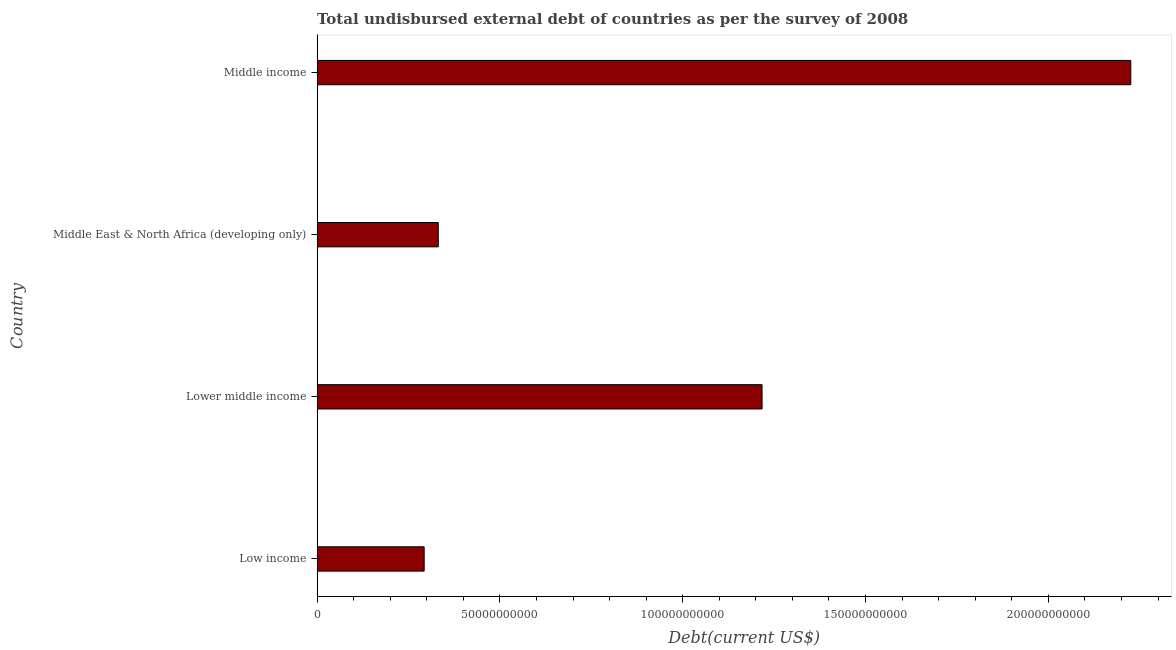Does the graph contain any zero values?
Offer a terse response. No. What is the title of the graph?
Your answer should be compact. Total undisbursed external debt of countries as per the survey of 2008. What is the label or title of the X-axis?
Ensure brevity in your answer.  Debt(current US$). What is the total debt in Lower middle income?
Provide a succinct answer. 1.22e+11. Across all countries, what is the maximum total debt?
Your answer should be compact. 2.23e+11. Across all countries, what is the minimum total debt?
Keep it short and to the point. 2.93e+1. In which country was the total debt minimum?
Your answer should be compact. Low income. What is the sum of the total debt?
Give a very brief answer. 4.07e+11. What is the difference between the total debt in Low income and Lower middle income?
Offer a terse response. -9.24e+1. What is the average total debt per country?
Provide a short and direct response. 1.02e+11. What is the median total debt?
Offer a very short reply. 7.74e+1. What is the ratio of the total debt in Lower middle income to that in Middle income?
Your answer should be very brief. 0.55. Is the difference between the total debt in Lower middle income and Middle East & North Africa (developing only) greater than the difference between any two countries?
Your answer should be very brief. No. What is the difference between the highest and the second highest total debt?
Keep it short and to the point. 1.01e+11. Is the sum of the total debt in Lower middle income and Middle income greater than the maximum total debt across all countries?
Ensure brevity in your answer.  Yes. What is the difference between the highest and the lowest total debt?
Ensure brevity in your answer.  1.93e+11. How many bars are there?
Your response must be concise. 4. How many countries are there in the graph?
Your response must be concise. 4. What is the Debt(current US$) of Low income?
Offer a very short reply. 2.93e+1. What is the Debt(current US$) of Lower middle income?
Keep it short and to the point. 1.22e+11. What is the Debt(current US$) in Middle East & North Africa (developing only)?
Make the answer very short. 3.31e+1. What is the Debt(current US$) in Middle income?
Your answer should be compact. 2.23e+11. What is the difference between the Debt(current US$) in Low income and Lower middle income?
Keep it short and to the point. -9.24e+1. What is the difference between the Debt(current US$) in Low income and Middle East & North Africa (developing only)?
Provide a succinct answer. -3.85e+09. What is the difference between the Debt(current US$) in Low income and Middle income?
Your answer should be very brief. -1.93e+11. What is the difference between the Debt(current US$) in Lower middle income and Middle East & North Africa (developing only)?
Offer a terse response. 8.86e+1. What is the difference between the Debt(current US$) in Lower middle income and Middle income?
Make the answer very short. -1.01e+11. What is the difference between the Debt(current US$) in Middle East & North Africa (developing only) and Middle income?
Give a very brief answer. -1.89e+11. What is the ratio of the Debt(current US$) in Low income to that in Lower middle income?
Provide a short and direct response. 0.24. What is the ratio of the Debt(current US$) in Low income to that in Middle East & North Africa (developing only)?
Your answer should be very brief. 0.88. What is the ratio of the Debt(current US$) in Low income to that in Middle income?
Your response must be concise. 0.13. What is the ratio of the Debt(current US$) in Lower middle income to that in Middle East & North Africa (developing only)?
Provide a short and direct response. 3.67. What is the ratio of the Debt(current US$) in Lower middle income to that in Middle income?
Your response must be concise. 0.55. What is the ratio of the Debt(current US$) in Middle East & North Africa (developing only) to that in Middle income?
Make the answer very short. 0.15. 